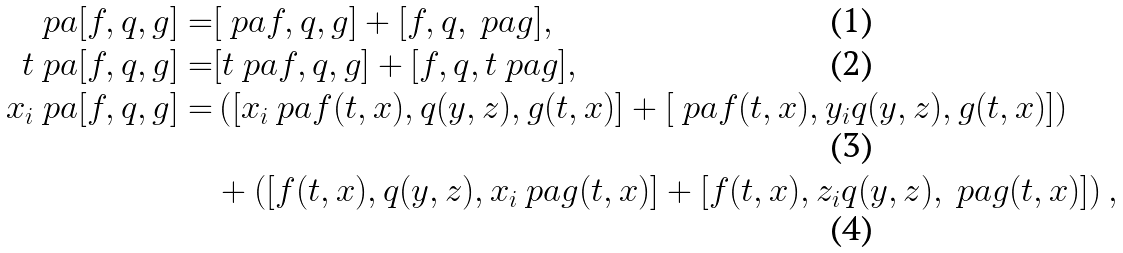Convert formula to latex. <formula><loc_0><loc_0><loc_500><loc_500>\ p a [ f , q , g ] = & [ \ p a f , q , g ] + [ f , q , \ p a g ] , \\ t \ p a [ f , q , g ] = & [ t \ p a f , q , g ] + [ f , q , t \ p a g ] , \\ x _ { i } \ p a [ f , q , g ] = & \left ( [ x _ { i } \ p a f ( t , x ) , q ( y , z ) , g ( t , x ) ] + [ \ p a f ( t , x ) , y _ { i } q ( y , z ) , g ( t , x ) ] \right ) \\ & + \left ( [ f ( t , x ) , q ( y , z ) , x _ { i } \ p a g ( t , x ) ] + [ f ( t , x ) , z _ { i } q ( y , z ) , \ p a g ( t , x ) ] \right ) ,</formula> 